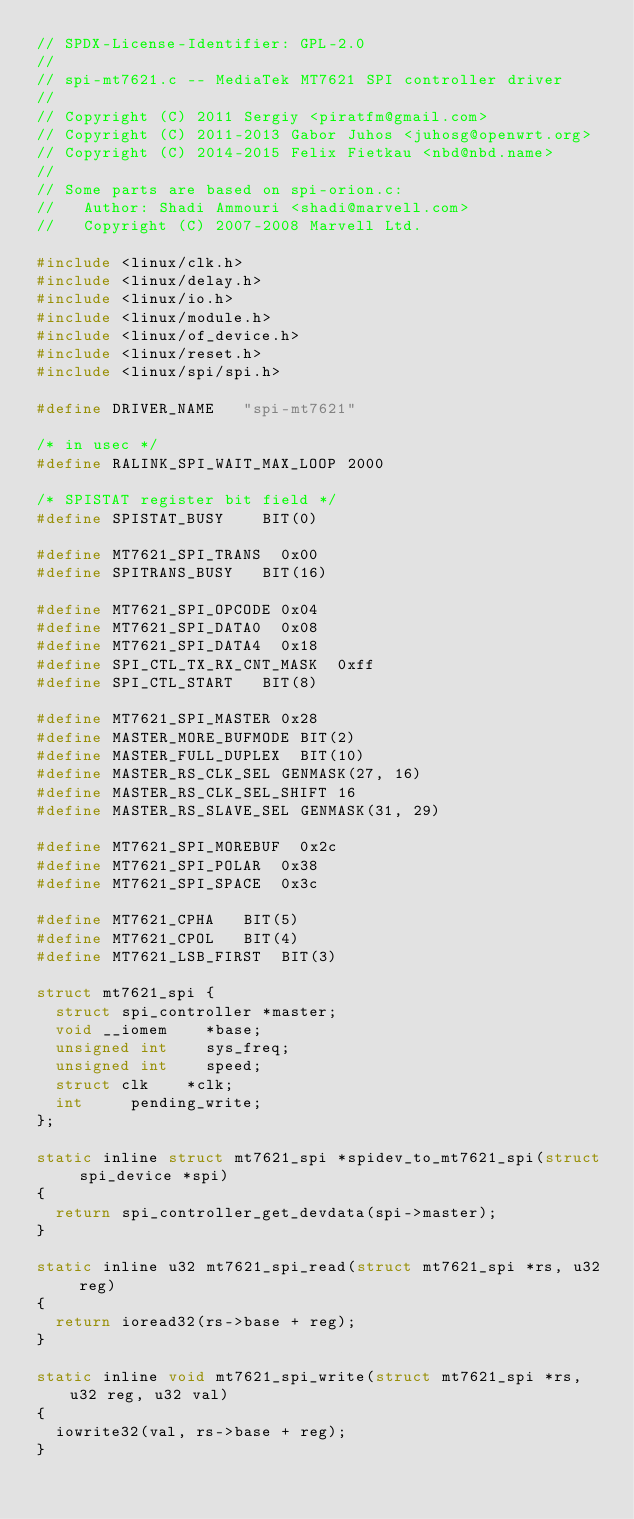Convert code to text. <code><loc_0><loc_0><loc_500><loc_500><_C_>// SPDX-License-Identifier: GPL-2.0
//
// spi-mt7621.c -- MediaTek MT7621 SPI controller driver
//
// Copyright (C) 2011 Sergiy <piratfm@gmail.com>
// Copyright (C) 2011-2013 Gabor Juhos <juhosg@openwrt.org>
// Copyright (C) 2014-2015 Felix Fietkau <nbd@nbd.name>
//
// Some parts are based on spi-orion.c:
//   Author: Shadi Ammouri <shadi@marvell.com>
//   Copyright (C) 2007-2008 Marvell Ltd.

#include <linux/clk.h>
#include <linux/delay.h>
#include <linux/io.h>
#include <linux/module.h>
#include <linux/of_device.h>
#include <linux/reset.h>
#include <linux/spi/spi.h>

#define DRIVER_NAME		"spi-mt7621"

/* in usec */
#define RALINK_SPI_WAIT_MAX_LOOP 2000

/* SPISTAT register bit field */
#define SPISTAT_BUSY		BIT(0)

#define MT7621_SPI_TRANS	0x00
#define SPITRANS_BUSY		BIT(16)

#define MT7621_SPI_OPCODE	0x04
#define MT7621_SPI_DATA0	0x08
#define MT7621_SPI_DATA4	0x18
#define SPI_CTL_TX_RX_CNT_MASK	0xff
#define SPI_CTL_START		BIT(8)

#define MT7621_SPI_MASTER	0x28
#define MASTER_MORE_BUFMODE	BIT(2)
#define MASTER_FULL_DUPLEX	BIT(10)
#define MASTER_RS_CLK_SEL	GENMASK(27, 16)
#define MASTER_RS_CLK_SEL_SHIFT	16
#define MASTER_RS_SLAVE_SEL	GENMASK(31, 29)

#define MT7621_SPI_MOREBUF	0x2c
#define MT7621_SPI_POLAR	0x38
#define MT7621_SPI_SPACE	0x3c

#define MT7621_CPHA		BIT(5)
#define MT7621_CPOL		BIT(4)
#define MT7621_LSB_FIRST	BIT(3)

struct mt7621_spi {
	struct spi_controller	*master;
	void __iomem		*base;
	unsigned int		sys_freq;
	unsigned int		speed;
	struct clk		*clk;
	int			pending_write;
};

static inline struct mt7621_spi *spidev_to_mt7621_spi(struct spi_device *spi)
{
	return spi_controller_get_devdata(spi->master);
}

static inline u32 mt7621_spi_read(struct mt7621_spi *rs, u32 reg)
{
	return ioread32(rs->base + reg);
}

static inline void mt7621_spi_write(struct mt7621_spi *rs, u32 reg, u32 val)
{
	iowrite32(val, rs->base + reg);
}
</code> 